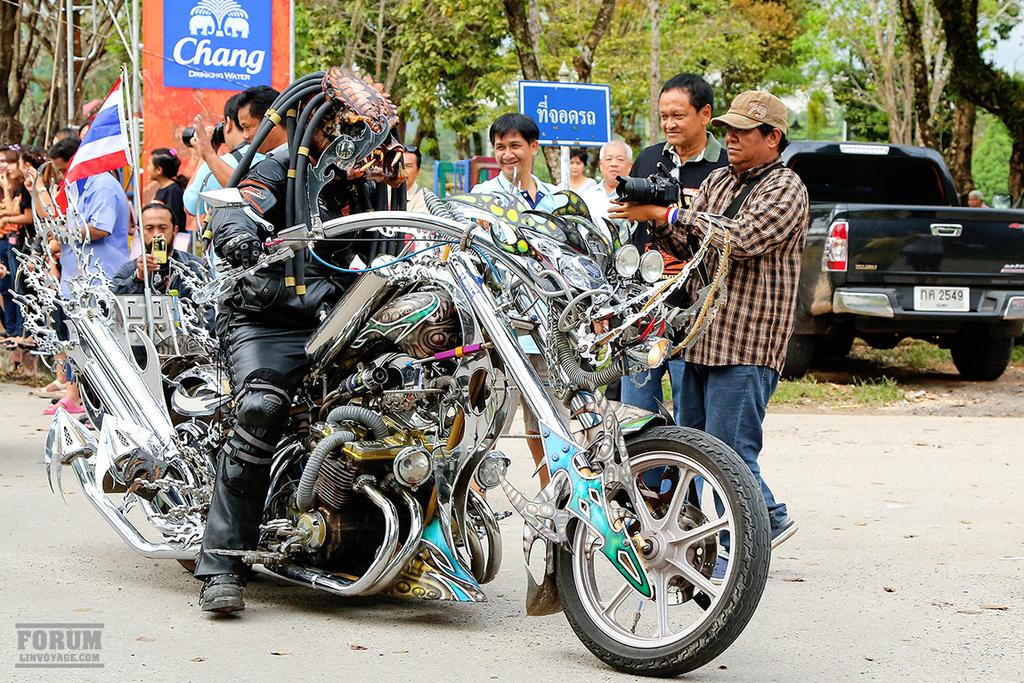What type of vehicle is depicted in the image? There is a vehicle in the shape of a dragon in the image. Who is on the dragon-shaped vehicle? A person is on the dragon-shaped vehicle. What is the position of the car in relation to the dragon-shaped vehicle? There is a car behind the dragon-shaped vehicle. Can you describe the people visible in the image? There are people visible in the image. What type of vegetation is present in the image? There are plants in the image. What is the price of the sky in the image? The sky is not for sale, and therefore there is no price associated with it in the image. 